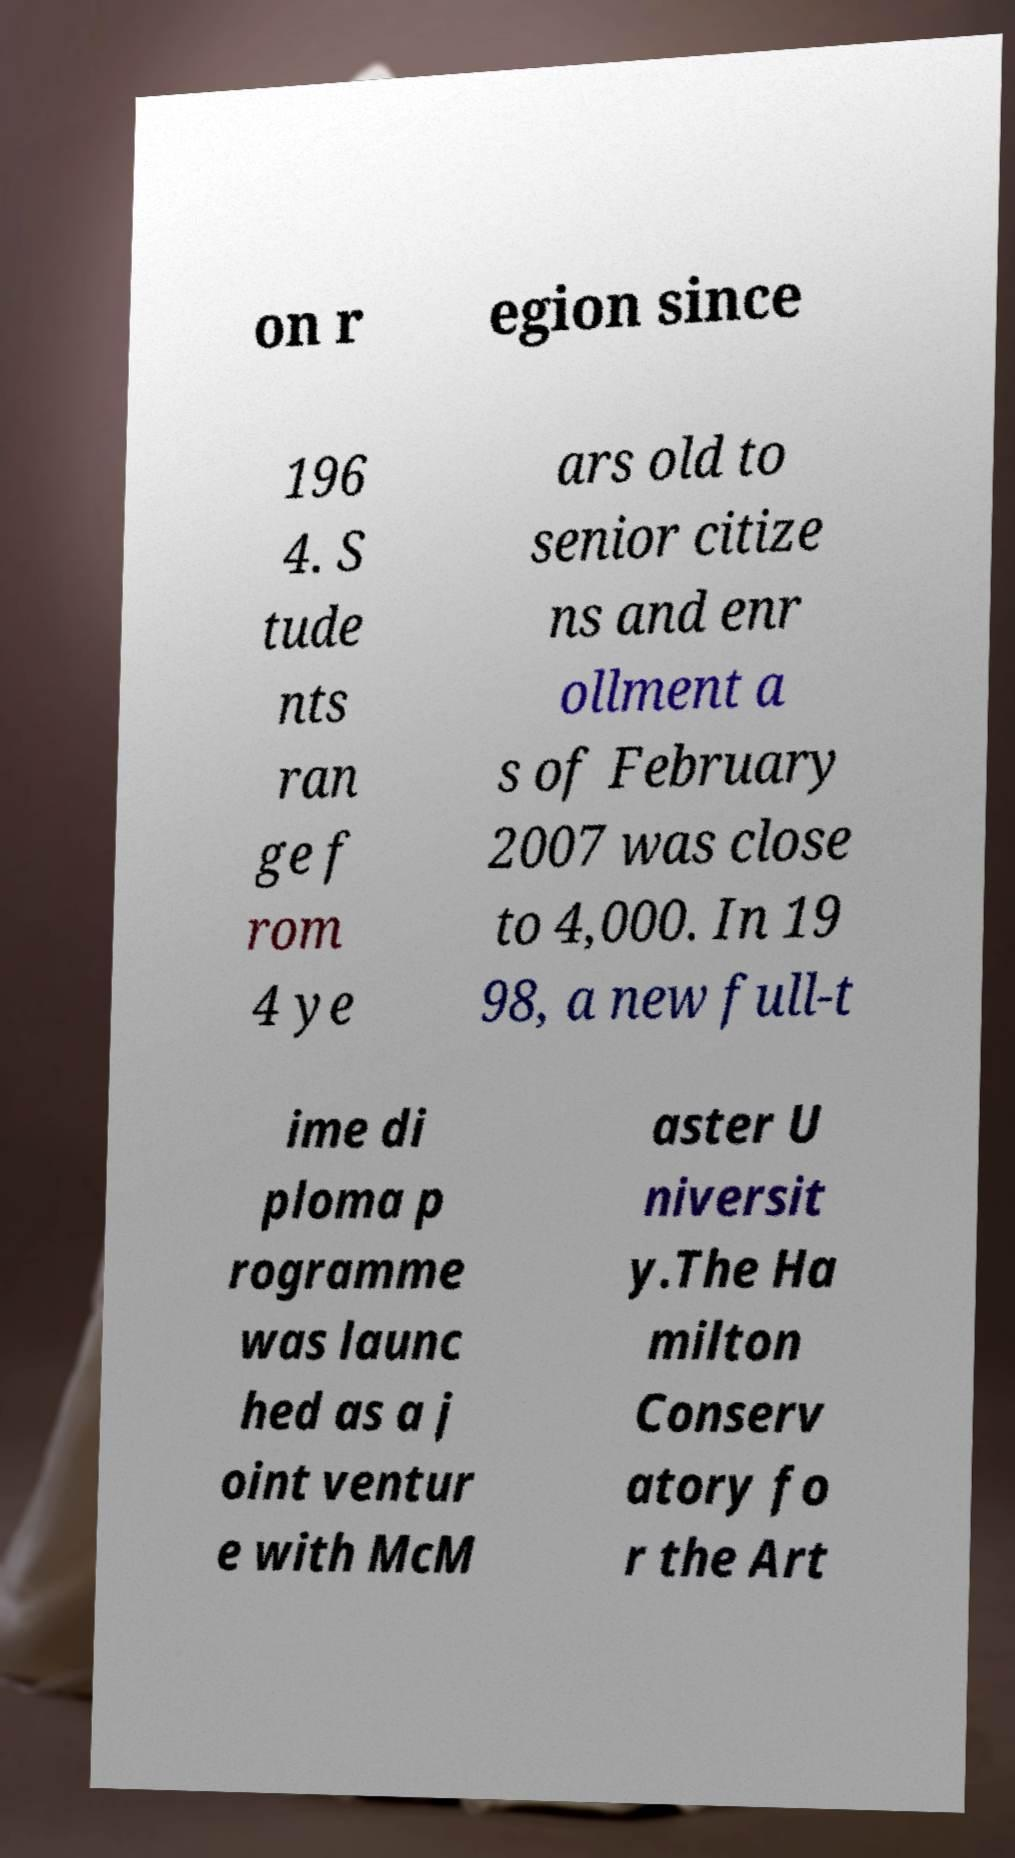For documentation purposes, I need the text within this image transcribed. Could you provide that? on r egion since 196 4. S tude nts ran ge f rom 4 ye ars old to senior citize ns and enr ollment a s of February 2007 was close to 4,000. In 19 98, a new full-t ime di ploma p rogramme was launc hed as a j oint ventur e with McM aster U niversit y.The Ha milton Conserv atory fo r the Art 